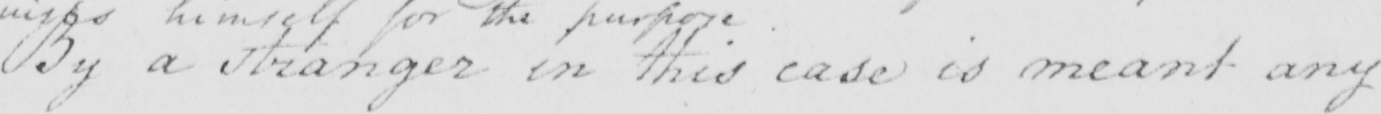What is written in this line of handwriting? By a stranger in this case is meant any 